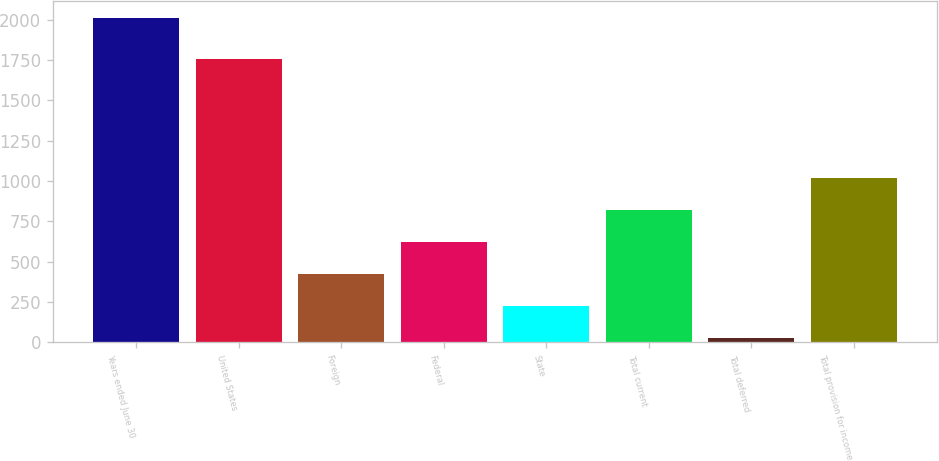Convert chart. <chart><loc_0><loc_0><loc_500><loc_500><bar_chart><fcel>Years ended June 30<fcel>United States<fcel>Foreign<fcel>Federal<fcel>State<fcel>Total current<fcel>Total deferred<fcel>Total provision for income<nl><fcel>2013<fcel>1757.6<fcel>422.36<fcel>621.19<fcel>223.53<fcel>820.02<fcel>24.7<fcel>1018.85<nl></chart> 